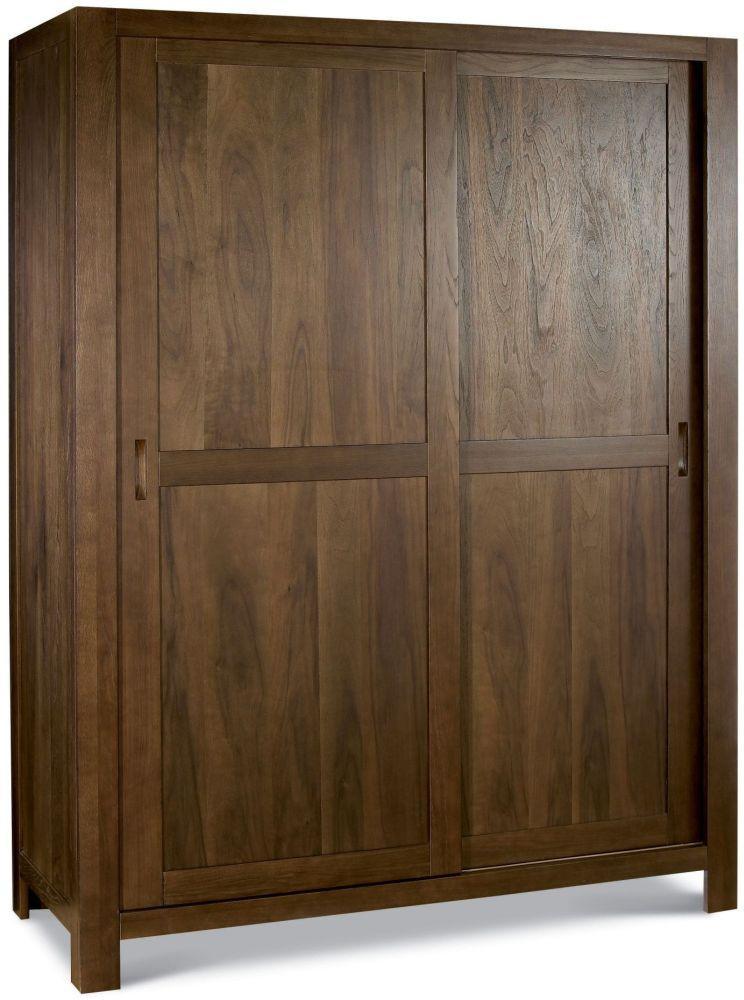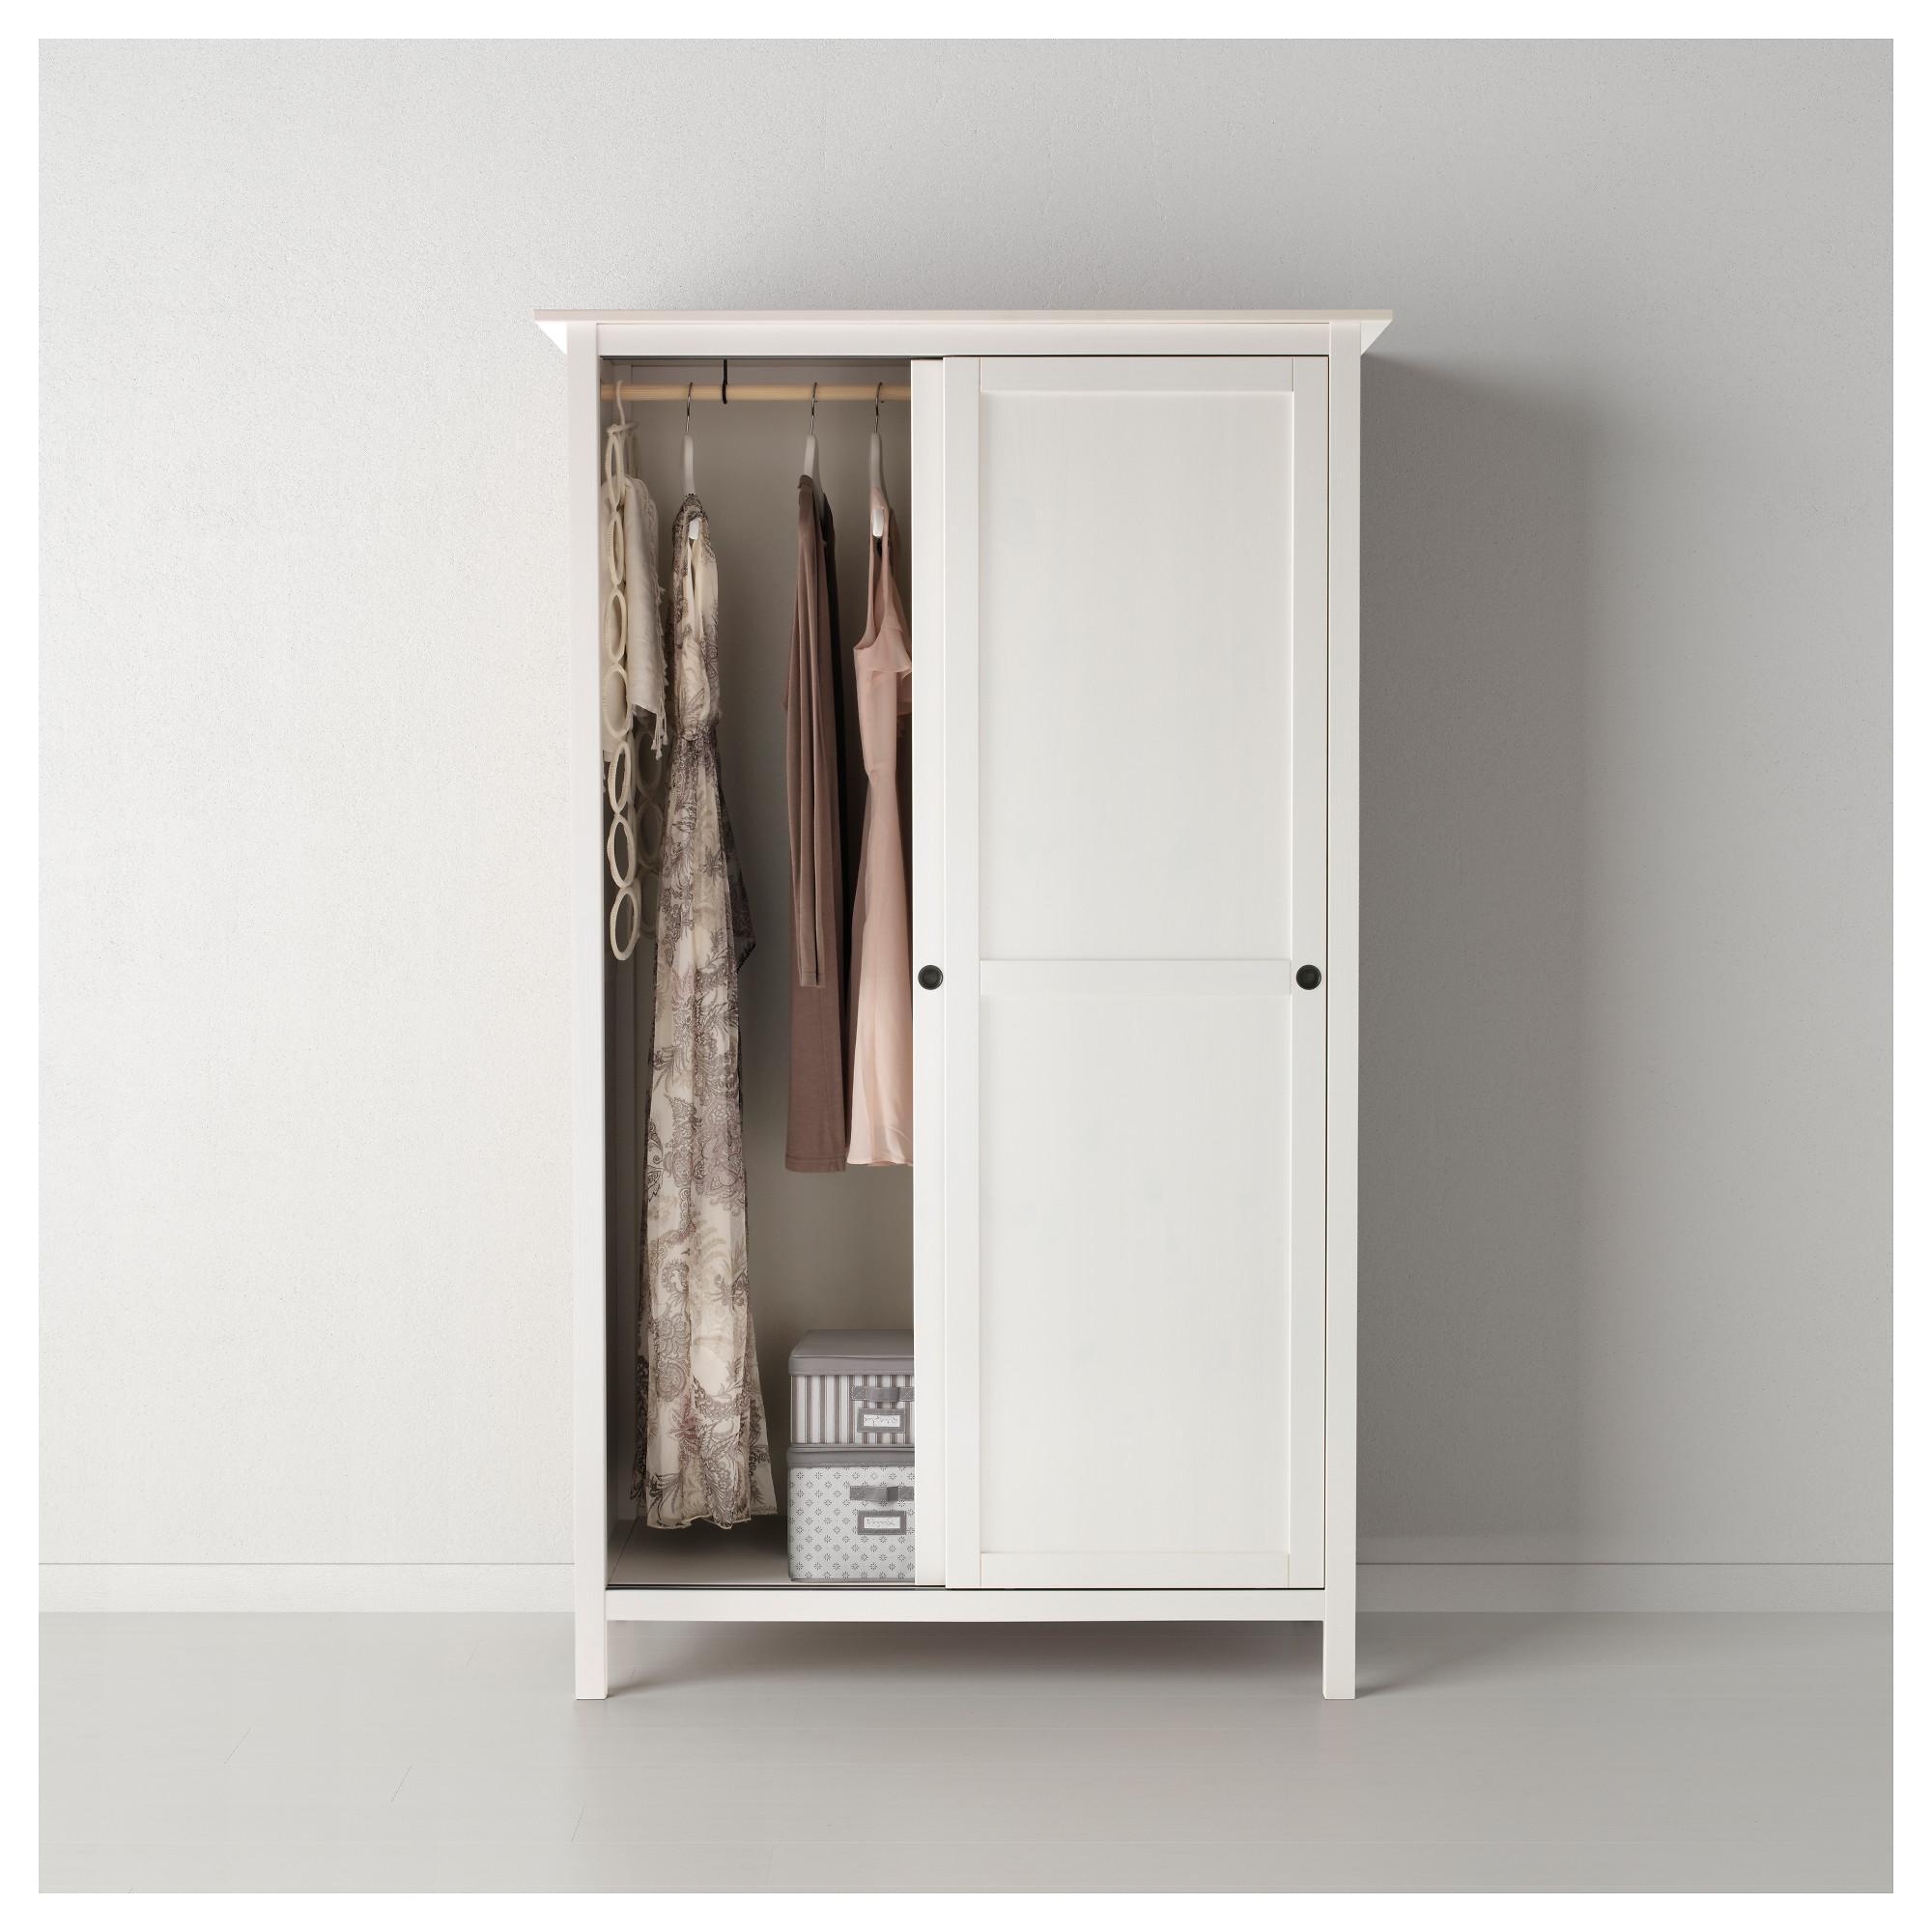The first image is the image on the left, the second image is the image on the right. Examine the images to the left and right. Is the description "One image shows a single white wardrobe, with an open area where clothes hang on the left." accurate? Answer yes or no. Yes. The first image is the image on the left, the second image is the image on the right. For the images displayed, is the sentence "Clothing is hanging in the wardrobe in the image on the right." factually correct? Answer yes or no. Yes. 